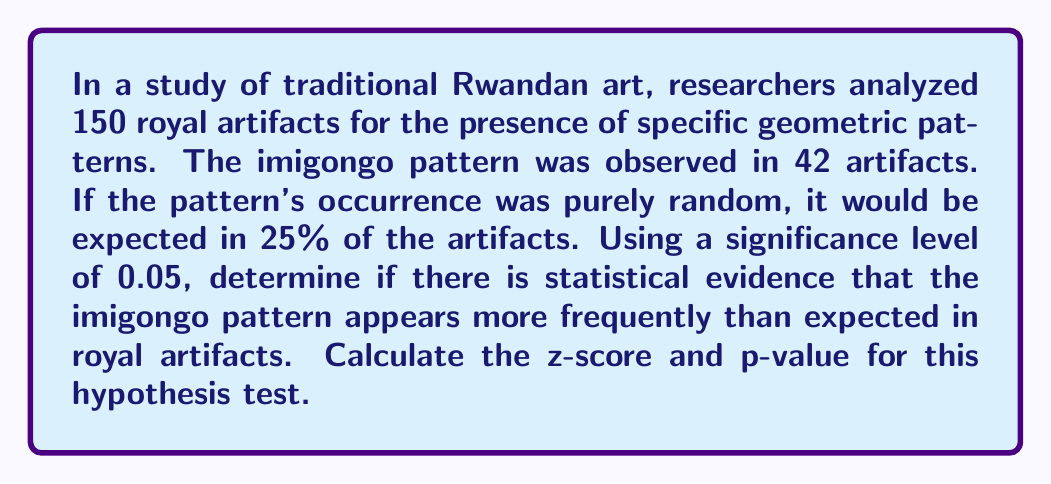Can you answer this question? To determine if there is statistical evidence that the imigongo pattern appears more frequently than expected, we'll conduct a one-tailed z-test for proportions.

Step 1: Define the null and alternative hypotheses
$H_0: p = 0.25$ (the proportion of artifacts with imigongo pattern is 25%)
$H_a: p > 0.25$ (the proportion is greater than 25%)

Step 2: Calculate the sample proportion
$\hat{p} = \frac{42}{150} = 0.28$

Step 3: Calculate the standard error
$SE = \sqrt{\frac{p_0(1-p_0)}{n}} = \sqrt{\frac{0.25(1-0.25)}{150}} = 0.0354$

Step 4: Calculate the z-score
$z = \frac{\hat{p} - p_0}{SE} = \frac{0.28 - 0.25}{0.0354} = 0.8475$

Step 5: Find the p-value
Using a standard normal distribution table or calculator, we find:
$p-value = P(Z > 0.8475) = 0.1984$

Step 6: Compare the p-value to the significance level
Since $0.1984 > 0.05$, we fail to reject the null hypothesis.
Answer: $z = 0.8475$, $p-value = 0.1984$. Fail to reject $H_0$. 